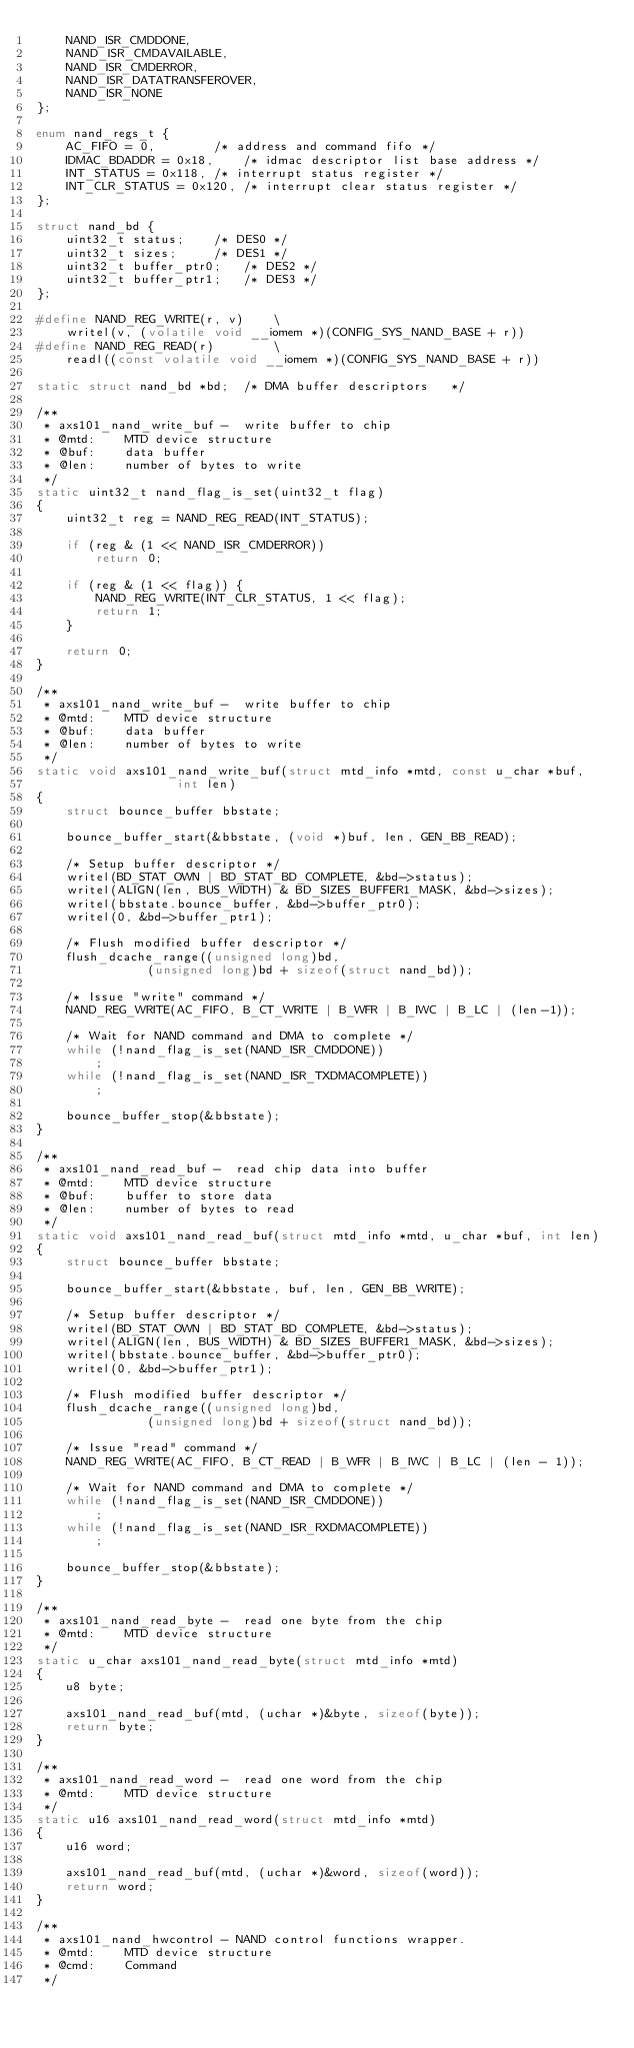<code> <loc_0><loc_0><loc_500><loc_500><_C_>	NAND_ISR_CMDDONE,
	NAND_ISR_CMDAVAILABLE,
	NAND_ISR_CMDERROR,
	NAND_ISR_DATATRANSFEROVER,
	NAND_ISR_NONE
};

enum nand_regs_t {
	AC_FIFO = 0,		/* address and command fifo */
	IDMAC_BDADDR = 0x18,	/* idmac descriptor list base address */
	INT_STATUS = 0x118,	/* interrupt status register */
	INT_CLR_STATUS = 0x120,	/* interrupt clear status register */
};

struct nand_bd {
	uint32_t status;	/* DES0 */
	uint32_t sizes;		/* DES1 */
	uint32_t buffer_ptr0;	/* DES2 */
	uint32_t buffer_ptr1;	/* DES3 */
};

#define NAND_REG_WRITE(r, v)	\
	writel(v, (volatile void __iomem *)(CONFIG_SYS_NAND_BASE + r))
#define NAND_REG_READ(r)		\
	readl((const volatile void __iomem *)(CONFIG_SYS_NAND_BASE + r))

static struct nand_bd *bd;	/* DMA buffer descriptors	*/

/**
 * axs101_nand_write_buf -  write buffer to chip
 * @mtd:	MTD device structure
 * @buf:	data buffer
 * @len:	number of bytes to write
 */
static uint32_t nand_flag_is_set(uint32_t flag)
{
	uint32_t reg = NAND_REG_READ(INT_STATUS);

	if (reg & (1 << NAND_ISR_CMDERROR))
		return 0;

	if (reg & (1 << flag)) {
		NAND_REG_WRITE(INT_CLR_STATUS, 1 << flag);
		return 1;
	}

	return 0;
}

/**
 * axs101_nand_write_buf -  write buffer to chip
 * @mtd:	MTD device structure
 * @buf:	data buffer
 * @len:	number of bytes to write
 */
static void axs101_nand_write_buf(struct mtd_info *mtd, const u_char *buf,
				   int len)
{
	struct bounce_buffer bbstate;

	bounce_buffer_start(&bbstate, (void *)buf, len, GEN_BB_READ);

	/* Setup buffer descriptor */
	writel(BD_STAT_OWN | BD_STAT_BD_COMPLETE, &bd->status);
	writel(ALIGN(len, BUS_WIDTH) & BD_SIZES_BUFFER1_MASK, &bd->sizes);
	writel(bbstate.bounce_buffer, &bd->buffer_ptr0);
	writel(0, &bd->buffer_ptr1);

	/* Flush modified buffer descriptor */
	flush_dcache_range((unsigned long)bd,
			   (unsigned long)bd + sizeof(struct nand_bd));

	/* Issue "write" command */
	NAND_REG_WRITE(AC_FIFO, B_CT_WRITE | B_WFR | B_IWC | B_LC | (len-1));

	/* Wait for NAND command and DMA to complete */
	while (!nand_flag_is_set(NAND_ISR_CMDDONE))
		;
	while (!nand_flag_is_set(NAND_ISR_TXDMACOMPLETE))
		;

	bounce_buffer_stop(&bbstate);
}

/**
 * axs101_nand_read_buf -  read chip data into buffer
 * @mtd:	MTD device structure
 * @buf:	buffer to store data
 * @len:	number of bytes to read
 */
static void axs101_nand_read_buf(struct mtd_info *mtd, u_char *buf, int len)
{
	struct bounce_buffer bbstate;

	bounce_buffer_start(&bbstate, buf, len, GEN_BB_WRITE);

	/* Setup buffer descriptor */
	writel(BD_STAT_OWN | BD_STAT_BD_COMPLETE, &bd->status);
	writel(ALIGN(len, BUS_WIDTH) & BD_SIZES_BUFFER1_MASK, &bd->sizes);
	writel(bbstate.bounce_buffer, &bd->buffer_ptr0);
	writel(0, &bd->buffer_ptr1);

	/* Flush modified buffer descriptor */
	flush_dcache_range((unsigned long)bd,
			   (unsigned long)bd + sizeof(struct nand_bd));

	/* Issue "read" command */
	NAND_REG_WRITE(AC_FIFO, B_CT_READ | B_WFR | B_IWC | B_LC | (len - 1));

	/* Wait for NAND command and DMA to complete */
	while (!nand_flag_is_set(NAND_ISR_CMDDONE))
		;
	while (!nand_flag_is_set(NAND_ISR_RXDMACOMPLETE))
		;

	bounce_buffer_stop(&bbstate);
}

/**
 * axs101_nand_read_byte -  read one byte from the chip
 * @mtd:	MTD device structure
 */
static u_char axs101_nand_read_byte(struct mtd_info *mtd)
{
	u8 byte;

	axs101_nand_read_buf(mtd, (uchar *)&byte, sizeof(byte));
	return byte;
}

/**
 * axs101_nand_read_word -  read one word from the chip
 * @mtd:	MTD device structure
 */
static u16 axs101_nand_read_word(struct mtd_info *mtd)
{
	u16 word;

	axs101_nand_read_buf(mtd, (uchar *)&word, sizeof(word));
	return word;
}

/**
 * axs101_nand_hwcontrol - NAND control functions wrapper.
 * @mtd:	MTD device structure
 * @cmd:	Command
 */</code> 